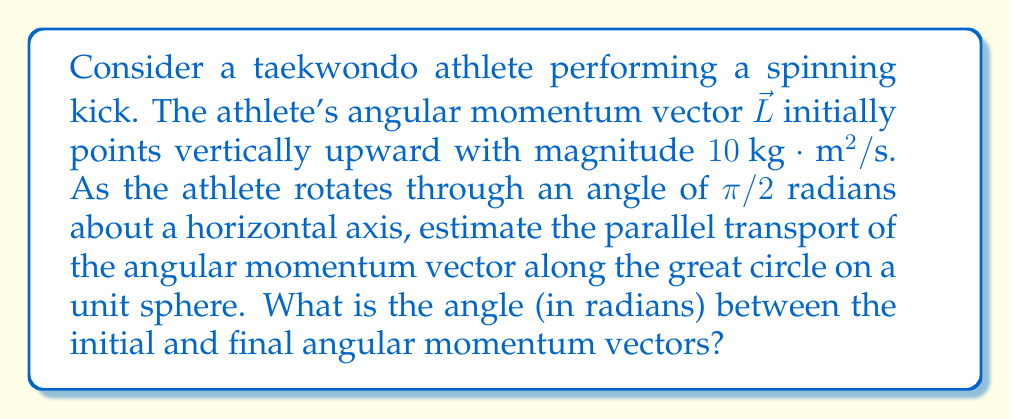Can you solve this math problem? Let's approach this step-by-step:

1) In differential geometry, parallel transport along a great circle on a sphere results in a rotation of vectors.

2) The angle of rotation of the transported vector is related to the solid angle enclosed by the path on the sphere.

3) For a path along a great circle spanning an angle $\theta$, the solid angle $\Omega$ is given by:

   $$\Omega = 2\tan^{-1}(\sin(\theta/2))$$

4) In this case, $\theta = \pi/2$ radians.

5) Substituting into the formula:

   $$\Omega = 2\tan^{-1}(\sin(\pi/4)) = 2\tan^{-1}(\frac{\sqrt{2}}{2})$$

6) The angle $\phi$ between the initial and final angular momentum vectors is equal to this solid angle:

   $$\phi = 2\tan^{-1}(\frac{\sqrt{2}}{2})$$

7) Evaluating this:

   $$\phi = 2 \cdot 0.6155 \approx 1.2310 \text{ radians}$$

Note: The magnitude of the angular momentum vector remains constant during parallel transport.
Answer: $1.2310 \text{ radians}$ 